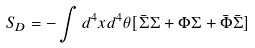<formula> <loc_0><loc_0><loc_500><loc_500>S _ { D } = - \int d ^ { 4 } x d ^ { 4 } \theta [ \bar { \Sigma } \Sigma + \Phi \Sigma + \bar { \Phi } \bar { \Sigma } ]</formula> 